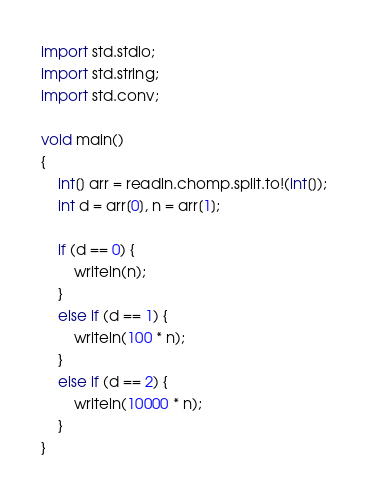Convert code to text. <code><loc_0><loc_0><loc_500><loc_500><_D_>import std.stdio;
import std.string;
import std.conv;

void main()
{
    int[] arr = readln.chomp.split.to!(int[]);
    int d = arr[0], n = arr[1];

    if (d == 0) {
        writeln(n);
    }
    else if (d == 1) {
        writeln(100 * n);
    }
    else if (d == 2) {
        writeln(10000 * n);
    }
}</code> 